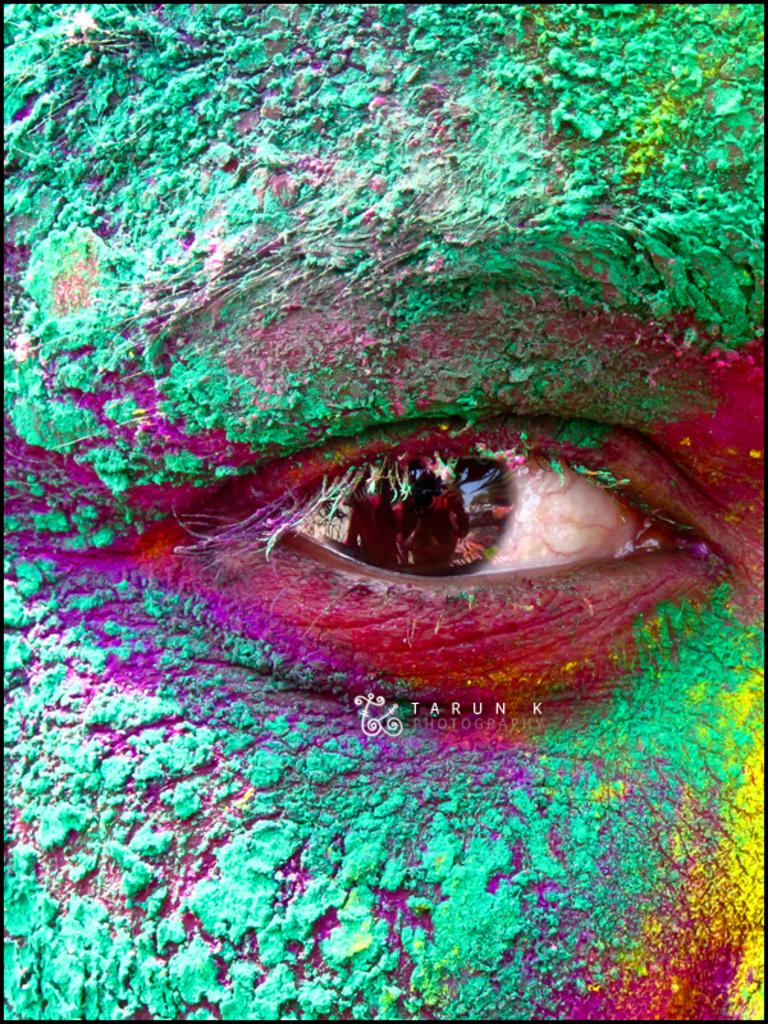What is the main subject of the image? The main subject of the image is the eye of a person. Are there any additional elements in the image besides the eye? Yes, there is a watermark in the image. What can be observed about the colors in the image? There are colors around the eye in the image. What is the tendency of the cows in the image? There are no cows present in the image, so it is not possible to determine their tendency. 